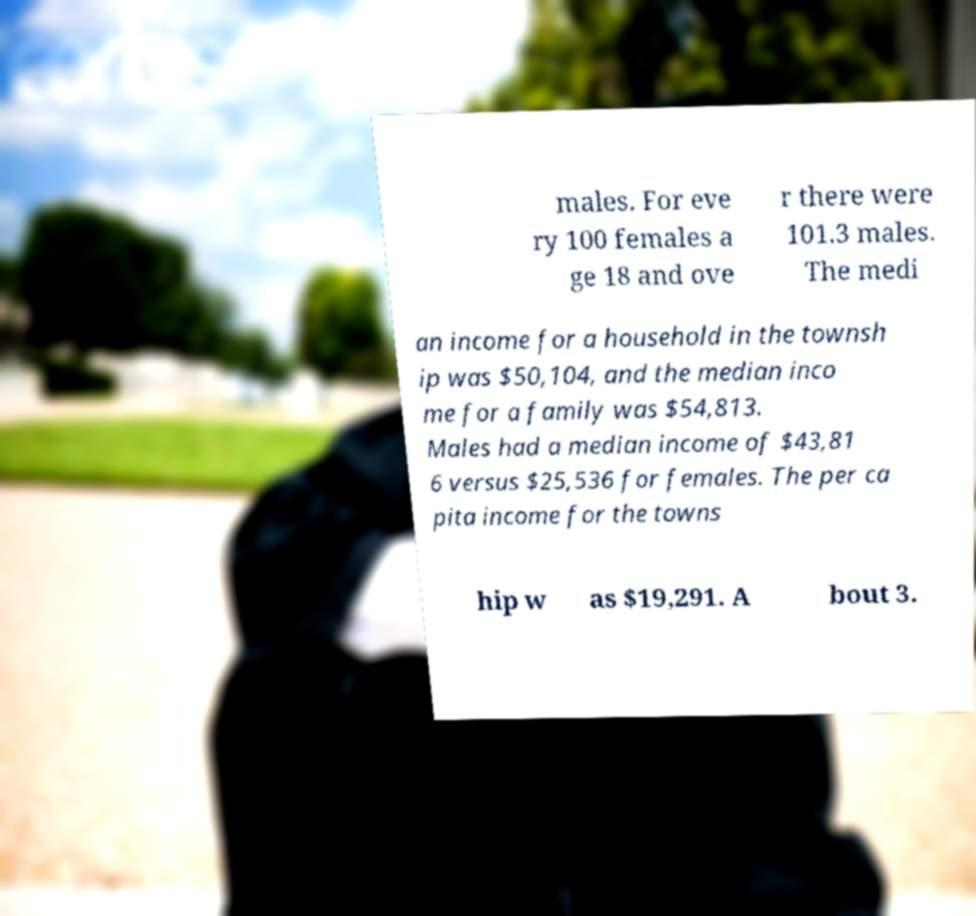For documentation purposes, I need the text within this image transcribed. Could you provide that? males. For eve ry 100 females a ge 18 and ove r there were 101.3 males. The medi an income for a household in the townsh ip was $50,104, and the median inco me for a family was $54,813. Males had a median income of $43,81 6 versus $25,536 for females. The per ca pita income for the towns hip w as $19,291. A bout 3. 